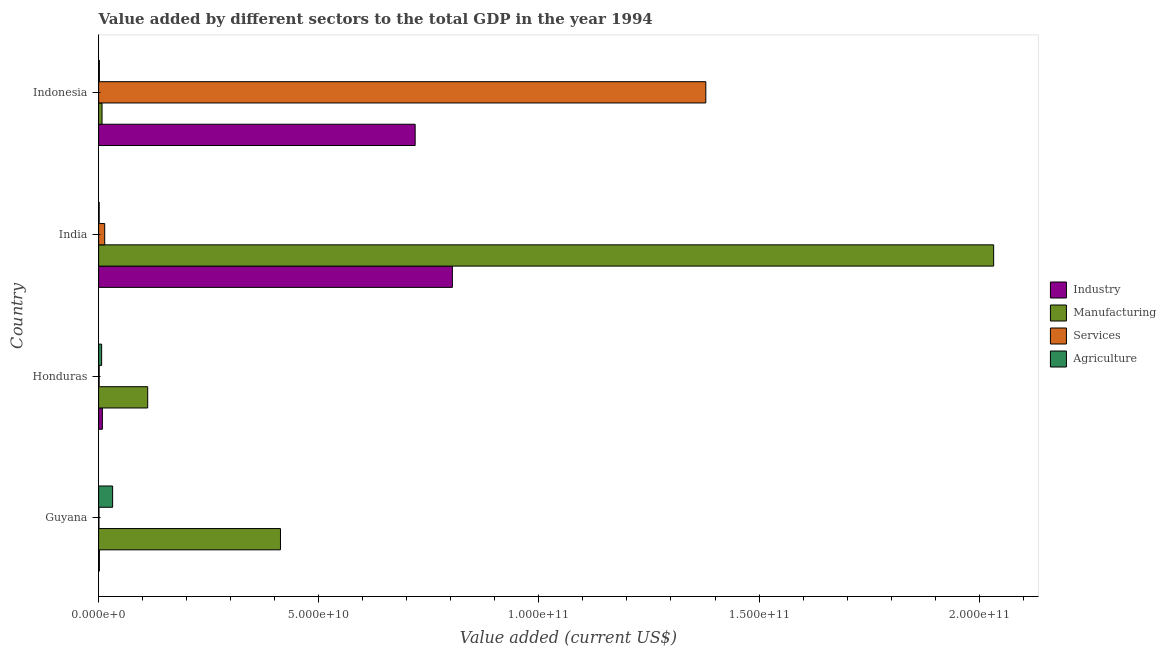How many different coloured bars are there?
Ensure brevity in your answer.  4. How many groups of bars are there?
Ensure brevity in your answer.  4. Are the number of bars on each tick of the Y-axis equal?
Provide a short and direct response. Yes. How many bars are there on the 4th tick from the bottom?
Provide a succinct answer. 4. What is the label of the 2nd group of bars from the top?
Offer a terse response. India. In how many cases, is the number of bars for a given country not equal to the number of legend labels?
Your answer should be very brief. 0. What is the value added by industrial sector in Guyana?
Your answer should be very brief. 1.67e+08. Across all countries, what is the maximum value added by agricultural sector?
Offer a terse response. 3.18e+09. Across all countries, what is the minimum value added by industrial sector?
Provide a short and direct response. 1.67e+08. In which country was the value added by industrial sector maximum?
Keep it short and to the point. India. In which country was the value added by industrial sector minimum?
Your answer should be compact. Guyana. What is the total value added by agricultural sector in the graph?
Provide a short and direct response. 4.15e+09. What is the difference between the value added by services sector in Guyana and that in Honduras?
Keep it short and to the point. -4.76e+07. What is the difference between the value added by manufacturing sector in Guyana and the value added by services sector in India?
Make the answer very short. 3.99e+1. What is the average value added by services sector per country?
Offer a very short reply. 3.49e+1. What is the difference between the value added by agricultural sector and value added by manufacturing sector in Guyana?
Give a very brief answer. -3.81e+1. In how many countries, is the value added by agricultural sector greater than 190000000000 US$?
Your answer should be compact. 0. What is the ratio of the value added by manufacturing sector in Honduras to that in Indonesia?
Offer a terse response. 14.43. Is the value added by industrial sector in Honduras less than that in Indonesia?
Give a very brief answer. Yes. What is the difference between the highest and the second highest value added by services sector?
Keep it short and to the point. 1.37e+11. What is the difference between the highest and the lowest value added by industrial sector?
Ensure brevity in your answer.  8.02e+1. Is the sum of the value added by industrial sector in Guyana and Honduras greater than the maximum value added by manufacturing sector across all countries?
Provide a short and direct response. No. What does the 4th bar from the top in India represents?
Provide a succinct answer. Industry. What does the 2nd bar from the bottom in Indonesia represents?
Provide a short and direct response. Manufacturing. How many bars are there?
Ensure brevity in your answer.  16. How many countries are there in the graph?
Give a very brief answer. 4. Are the values on the major ticks of X-axis written in scientific E-notation?
Keep it short and to the point. Yes. Does the graph contain grids?
Give a very brief answer. No. Where does the legend appear in the graph?
Offer a very short reply. Center right. How many legend labels are there?
Give a very brief answer. 4. What is the title of the graph?
Offer a very short reply. Value added by different sectors to the total GDP in the year 1994. Does "CO2 damage" appear as one of the legend labels in the graph?
Your answer should be very brief. No. What is the label or title of the X-axis?
Provide a succinct answer. Value added (current US$). What is the Value added (current US$) in Industry in Guyana?
Make the answer very short. 1.67e+08. What is the Value added (current US$) in Manufacturing in Guyana?
Your response must be concise. 4.13e+1. What is the Value added (current US$) in Services in Guyana?
Make the answer very short. 7.28e+07. What is the Value added (current US$) of Agriculture in Guyana?
Your answer should be very brief. 3.18e+09. What is the Value added (current US$) in Industry in Honduras?
Ensure brevity in your answer.  8.48e+08. What is the Value added (current US$) in Manufacturing in Honduras?
Provide a short and direct response. 1.11e+1. What is the Value added (current US$) in Services in Honduras?
Your answer should be very brief. 1.20e+08. What is the Value added (current US$) of Agriculture in Honduras?
Give a very brief answer. 6.82e+08. What is the Value added (current US$) in Industry in India?
Give a very brief answer. 8.03e+1. What is the Value added (current US$) in Manufacturing in India?
Ensure brevity in your answer.  2.03e+11. What is the Value added (current US$) of Services in India?
Give a very brief answer. 1.38e+09. What is the Value added (current US$) of Agriculture in India?
Provide a succinct answer. 1.23e+08. What is the Value added (current US$) in Industry in Indonesia?
Offer a very short reply. 7.19e+1. What is the Value added (current US$) in Manufacturing in Indonesia?
Offer a terse response. 7.72e+08. What is the Value added (current US$) of Services in Indonesia?
Offer a terse response. 1.38e+11. What is the Value added (current US$) of Agriculture in Indonesia?
Provide a short and direct response. 1.69e+08. Across all countries, what is the maximum Value added (current US$) in Industry?
Your answer should be compact. 8.03e+1. Across all countries, what is the maximum Value added (current US$) of Manufacturing?
Keep it short and to the point. 2.03e+11. Across all countries, what is the maximum Value added (current US$) of Services?
Your answer should be very brief. 1.38e+11. Across all countries, what is the maximum Value added (current US$) of Agriculture?
Offer a terse response. 3.18e+09. Across all countries, what is the minimum Value added (current US$) of Industry?
Your answer should be compact. 1.67e+08. Across all countries, what is the minimum Value added (current US$) in Manufacturing?
Provide a short and direct response. 7.72e+08. Across all countries, what is the minimum Value added (current US$) in Services?
Provide a short and direct response. 7.28e+07. Across all countries, what is the minimum Value added (current US$) of Agriculture?
Give a very brief answer. 1.23e+08. What is the total Value added (current US$) of Industry in the graph?
Make the answer very short. 1.53e+11. What is the total Value added (current US$) of Manufacturing in the graph?
Give a very brief answer. 2.57e+11. What is the total Value added (current US$) of Services in the graph?
Offer a very short reply. 1.39e+11. What is the total Value added (current US$) in Agriculture in the graph?
Give a very brief answer. 4.15e+09. What is the difference between the Value added (current US$) in Industry in Guyana and that in Honduras?
Your answer should be very brief. -6.81e+08. What is the difference between the Value added (current US$) in Manufacturing in Guyana and that in Honduras?
Your answer should be very brief. 3.02e+1. What is the difference between the Value added (current US$) in Services in Guyana and that in Honduras?
Offer a terse response. -4.76e+07. What is the difference between the Value added (current US$) in Agriculture in Guyana and that in Honduras?
Offer a terse response. 2.50e+09. What is the difference between the Value added (current US$) of Industry in Guyana and that in India?
Make the answer very short. -8.02e+1. What is the difference between the Value added (current US$) of Manufacturing in Guyana and that in India?
Ensure brevity in your answer.  -1.62e+11. What is the difference between the Value added (current US$) in Services in Guyana and that in India?
Offer a very short reply. -1.31e+09. What is the difference between the Value added (current US$) in Agriculture in Guyana and that in India?
Provide a succinct answer. 3.06e+09. What is the difference between the Value added (current US$) in Industry in Guyana and that in Indonesia?
Offer a terse response. -7.17e+1. What is the difference between the Value added (current US$) of Manufacturing in Guyana and that in Indonesia?
Offer a terse response. 4.05e+1. What is the difference between the Value added (current US$) of Services in Guyana and that in Indonesia?
Your answer should be very brief. -1.38e+11. What is the difference between the Value added (current US$) of Agriculture in Guyana and that in Indonesia?
Your response must be concise. 3.01e+09. What is the difference between the Value added (current US$) in Industry in Honduras and that in India?
Keep it short and to the point. -7.95e+1. What is the difference between the Value added (current US$) in Manufacturing in Honduras and that in India?
Make the answer very short. -1.92e+11. What is the difference between the Value added (current US$) of Services in Honduras and that in India?
Offer a terse response. -1.26e+09. What is the difference between the Value added (current US$) in Agriculture in Honduras and that in India?
Provide a short and direct response. 5.59e+08. What is the difference between the Value added (current US$) in Industry in Honduras and that in Indonesia?
Offer a terse response. -7.10e+1. What is the difference between the Value added (current US$) of Manufacturing in Honduras and that in Indonesia?
Your answer should be compact. 1.04e+1. What is the difference between the Value added (current US$) in Services in Honduras and that in Indonesia?
Keep it short and to the point. -1.38e+11. What is the difference between the Value added (current US$) of Agriculture in Honduras and that in Indonesia?
Make the answer very short. 5.13e+08. What is the difference between the Value added (current US$) in Industry in India and that in Indonesia?
Keep it short and to the point. 8.45e+09. What is the difference between the Value added (current US$) in Manufacturing in India and that in Indonesia?
Provide a short and direct response. 2.03e+11. What is the difference between the Value added (current US$) of Services in India and that in Indonesia?
Keep it short and to the point. -1.37e+11. What is the difference between the Value added (current US$) of Agriculture in India and that in Indonesia?
Make the answer very short. -4.58e+07. What is the difference between the Value added (current US$) in Industry in Guyana and the Value added (current US$) in Manufacturing in Honduras?
Your answer should be very brief. -1.10e+1. What is the difference between the Value added (current US$) of Industry in Guyana and the Value added (current US$) of Services in Honduras?
Your answer should be compact. 4.71e+07. What is the difference between the Value added (current US$) in Industry in Guyana and the Value added (current US$) in Agriculture in Honduras?
Provide a short and direct response. -5.15e+08. What is the difference between the Value added (current US$) in Manufacturing in Guyana and the Value added (current US$) in Services in Honduras?
Offer a very short reply. 4.12e+1. What is the difference between the Value added (current US$) of Manufacturing in Guyana and the Value added (current US$) of Agriculture in Honduras?
Offer a terse response. 4.06e+1. What is the difference between the Value added (current US$) in Services in Guyana and the Value added (current US$) in Agriculture in Honduras?
Your answer should be compact. -6.10e+08. What is the difference between the Value added (current US$) in Industry in Guyana and the Value added (current US$) in Manufacturing in India?
Provide a succinct answer. -2.03e+11. What is the difference between the Value added (current US$) in Industry in Guyana and the Value added (current US$) in Services in India?
Give a very brief answer. -1.21e+09. What is the difference between the Value added (current US$) of Industry in Guyana and the Value added (current US$) of Agriculture in India?
Keep it short and to the point. 4.43e+07. What is the difference between the Value added (current US$) in Manufacturing in Guyana and the Value added (current US$) in Services in India?
Your response must be concise. 3.99e+1. What is the difference between the Value added (current US$) in Manufacturing in Guyana and the Value added (current US$) in Agriculture in India?
Keep it short and to the point. 4.12e+1. What is the difference between the Value added (current US$) in Services in Guyana and the Value added (current US$) in Agriculture in India?
Keep it short and to the point. -5.04e+07. What is the difference between the Value added (current US$) in Industry in Guyana and the Value added (current US$) in Manufacturing in Indonesia?
Ensure brevity in your answer.  -6.05e+08. What is the difference between the Value added (current US$) of Industry in Guyana and the Value added (current US$) of Services in Indonesia?
Your response must be concise. -1.38e+11. What is the difference between the Value added (current US$) of Industry in Guyana and the Value added (current US$) of Agriculture in Indonesia?
Keep it short and to the point. -1.50e+06. What is the difference between the Value added (current US$) in Manufacturing in Guyana and the Value added (current US$) in Services in Indonesia?
Provide a succinct answer. -9.66e+1. What is the difference between the Value added (current US$) of Manufacturing in Guyana and the Value added (current US$) of Agriculture in Indonesia?
Provide a succinct answer. 4.11e+1. What is the difference between the Value added (current US$) of Services in Guyana and the Value added (current US$) of Agriculture in Indonesia?
Your answer should be very brief. -9.61e+07. What is the difference between the Value added (current US$) of Industry in Honduras and the Value added (current US$) of Manufacturing in India?
Give a very brief answer. -2.02e+11. What is the difference between the Value added (current US$) of Industry in Honduras and the Value added (current US$) of Services in India?
Provide a succinct answer. -5.32e+08. What is the difference between the Value added (current US$) in Industry in Honduras and the Value added (current US$) in Agriculture in India?
Give a very brief answer. 7.25e+08. What is the difference between the Value added (current US$) of Manufacturing in Honduras and the Value added (current US$) of Services in India?
Make the answer very short. 9.76e+09. What is the difference between the Value added (current US$) in Manufacturing in Honduras and the Value added (current US$) in Agriculture in India?
Your response must be concise. 1.10e+1. What is the difference between the Value added (current US$) in Services in Honduras and the Value added (current US$) in Agriculture in India?
Keep it short and to the point. -2.83e+06. What is the difference between the Value added (current US$) of Industry in Honduras and the Value added (current US$) of Manufacturing in Indonesia?
Your answer should be very brief. 7.61e+07. What is the difference between the Value added (current US$) in Industry in Honduras and the Value added (current US$) in Services in Indonesia?
Your answer should be compact. -1.37e+11. What is the difference between the Value added (current US$) in Industry in Honduras and the Value added (current US$) in Agriculture in Indonesia?
Provide a short and direct response. 6.79e+08. What is the difference between the Value added (current US$) in Manufacturing in Honduras and the Value added (current US$) in Services in Indonesia?
Your response must be concise. -1.27e+11. What is the difference between the Value added (current US$) of Manufacturing in Honduras and the Value added (current US$) of Agriculture in Indonesia?
Your answer should be very brief. 1.10e+1. What is the difference between the Value added (current US$) of Services in Honduras and the Value added (current US$) of Agriculture in Indonesia?
Your answer should be very brief. -4.86e+07. What is the difference between the Value added (current US$) in Industry in India and the Value added (current US$) in Manufacturing in Indonesia?
Offer a very short reply. 7.96e+1. What is the difference between the Value added (current US$) of Industry in India and the Value added (current US$) of Services in Indonesia?
Provide a succinct answer. -5.76e+1. What is the difference between the Value added (current US$) of Industry in India and the Value added (current US$) of Agriculture in Indonesia?
Offer a terse response. 8.02e+1. What is the difference between the Value added (current US$) in Manufacturing in India and the Value added (current US$) in Services in Indonesia?
Your response must be concise. 6.54e+1. What is the difference between the Value added (current US$) in Manufacturing in India and the Value added (current US$) in Agriculture in Indonesia?
Keep it short and to the point. 2.03e+11. What is the difference between the Value added (current US$) in Services in India and the Value added (current US$) in Agriculture in Indonesia?
Keep it short and to the point. 1.21e+09. What is the average Value added (current US$) of Industry per country?
Make the answer very short. 3.83e+1. What is the average Value added (current US$) of Manufacturing per country?
Offer a terse response. 6.41e+1. What is the average Value added (current US$) in Services per country?
Offer a very short reply. 3.49e+1. What is the average Value added (current US$) in Agriculture per country?
Give a very brief answer. 1.04e+09. What is the difference between the Value added (current US$) of Industry and Value added (current US$) of Manufacturing in Guyana?
Your answer should be very brief. -4.11e+1. What is the difference between the Value added (current US$) of Industry and Value added (current US$) of Services in Guyana?
Ensure brevity in your answer.  9.46e+07. What is the difference between the Value added (current US$) of Industry and Value added (current US$) of Agriculture in Guyana?
Offer a terse response. -3.01e+09. What is the difference between the Value added (current US$) in Manufacturing and Value added (current US$) in Services in Guyana?
Give a very brief answer. 4.12e+1. What is the difference between the Value added (current US$) in Manufacturing and Value added (current US$) in Agriculture in Guyana?
Your answer should be very brief. 3.81e+1. What is the difference between the Value added (current US$) in Services and Value added (current US$) in Agriculture in Guyana?
Offer a very short reply. -3.11e+09. What is the difference between the Value added (current US$) of Industry and Value added (current US$) of Manufacturing in Honduras?
Provide a short and direct response. -1.03e+1. What is the difference between the Value added (current US$) in Industry and Value added (current US$) in Services in Honduras?
Offer a very short reply. 7.28e+08. What is the difference between the Value added (current US$) of Industry and Value added (current US$) of Agriculture in Honduras?
Your response must be concise. 1.66e+08. What is the difference between the Value added (current US$) of Manufacturing and Value added (current US$) of Services in Honduras?
Provide a succinct answer. 1.10e+1. What is the difference between the Value added (current US$) in Manufacturing and Value added (current US$) in Agriculture in Honduras?
Your answer should be very brief. 1.05e+1. What is the difference between the Value added (current US$) in Services and Value added (current US$) in Agriculture in Honduras?
Offer a terse response. -5.62e+08. What is the difference between the Value added (current US$) of Industry and Value added (current US$) of Manufacturing in India?
Ensure brevity in your answer.  -1.23e+11. What is the difference between the Value added (current US$) in Industry and Value added (current US$) in Services in India?
Offer a terse response. 7.90e+1. What is the difference between the Value added (current US$) of Industry and Value added (current US$) of Agriculture in India?
Make the answer very short. 8.02e+1. What is the difference between the Value added (current US$) in Manufacturing and Value added (current US$) in Services in India?
Ensure brevity in your answer.  2.02e+11. What is the difference between the Value added (current US$) of Manufacturing and Value added (current US$) of Agriculture in India?
Your response must be concise. 2.03e+11. What is the difference between the Value added (current US$) of Services and Value added (current US$) of Agriculture in India?
Your answer should be compact. 1.26e+09. What is the difference between the Value added (current US$) of Industry and Value added (current US$) of Manufacturing in Indonesia?
Your response must be concise. 7.11e+1. What is the difference between the Value added (current US$) of Industry and Value added (current US$) of Services in Indonesia?
Give a very brief answer. -6.60e+1. What is the difference between the Value added (current US$) in Industry and Value added (current US$) in Agriculture in Indonesia?
Ensure brevity in your answer.  7.17e+1. What is the difference between the Value added (current US$) of Manufacturing and Value added (current US$) of Services in Indonesia?
Provide a succinct answer. -1.37e+11. What is the difference between the Value added (current US$) in Manufacturing and Value added (current US$) in Agriculture in Indonesia?
Provide a succinct answer. 6.03e+08. What is the difference between the Value added (current US$) in Services and Value added (current US$) in Agriculture in Indonesia?
Keep it short and to the point. 1.38e+11. What is the ratio of the Value added (current US$) of Industry in Guyana to that in Honduras?
Your answer should be compact. 0.2. What is the ratio of the Value added (current US$) of Manufacturing in Guyana to that in Honduras?
Your response must be concise. 3.71. What is the ratio of the Value added (current US$) of Services in Guyana to that in Honduras?
Provide a succinct answer. 0.6. What is the ratio of the Value added (current US$) in Agriculture in Guyana to that in Honduras?
Make the answer very short. 4.66. What is the ratio of the Value added (current US$) of Industry in Guyana to that in India?
Your answer should be very brief. 0. What is the ratio of the Value added (current US$) of Manufacturing in Guyana to that in India?
Keep it short and to the point. 0.2. What is the ratio of the Value added (current US$) in Services in Guyana to that in India?
Ensure brevity in your answer.  0.05. What is the ratio of the Value added (current US$) in Agriculture in Guyana to that in India?
Give a very brief answer. 25.82. What is the ratio of the Value added (current US$) in Industry in Guyana to that in Indonesia?
Keep it short and to the point. 0. What is the ratio of the Value added (current US$) in Manufacturing in Guyana to that in Indonesia?
Your response must be concise. 53.49. What is the ratio of the Value added (current US$) of Agriculture in Guyana to that in Indonesia?
Provide a succinct answer. 18.82. What is the ratio of the Value added (current US$) in Industry in Honduras to that in India?
Ensure brevity in your answer.  0.01. What is the ratio of the Value added (current US$) in Manufacturing in Honduras to that in India?
Offer a very short reply. 0.05. What is the ratio of the Value added (current US$) of Services in Honduras to that in India?
Your answer should be compact. 0.09. What is the ratio of the Value added (current US$) in Agriculture in Honduras to that in India?
Keep it short and to the point. 5.54. What is the ratio of the Value added (current US$) in Industry in Honduras to that in Indonesia?
Make the answer very short. 0.01. What is the ratio of the Value added (current US$) of Manufacturing in Honduras to that in Indonesia?
Ensure brevity in your answer.  14.43. What is the ratio of the Value added (current US$) of Services in Honduras to that in Indonesia?
Give a very brief answer. 0. What is the ratio of the Value added (current US$) in Agriculture in Honduras to that in Indonesia?
Your response must be concise. 4.04. What is the ratio of the Value added (current US$) of Industry in India to that in Indonesia?
Offer a terse response. 1.12. What is the ratio of the Value added (current US$) in Manufacturing in India to that in Indonesia?
Give a very brief answer. 263.28. What is the ratio of the Value added (current US$) of Agriculture in India to that in Indonesia?
Ensure brevity in your answer.  0.73. What is the difference between the highest and the second highest Value added (current US$) of Industry?
Provide a short and direct response. 8.45e+09. What is the difference between the highest and the second highest Value added (current US$) in Manufacturing?
Ensure brevity in your answer.  1.62e+11. What is the difference between the highest and the second highest Value added (current US$) of Services?
Provide a short and direct response. 1.37e+11. What is the difference between the highest and the second highest Value added (current US$) in Agriculture?
Ensure brevity in your answer.  2.50e+09. What is the difference between the highest and the lowest Value added (current US$) in Industry?
Make the answer very short. 8.02e+1. What is the difference between the highest and the lowest Value added (current US$) of Manufacturing?
Offer a terse response. 2.03e+11. What is the difference between the highest and the lowest Value added (current US$) in Services?
Offer a terse response. 1.38e+11. What is the difference between the highest and the lowest Value added (current US$) of Agriculture?
Offer a very short reply. 3.06e+09. 